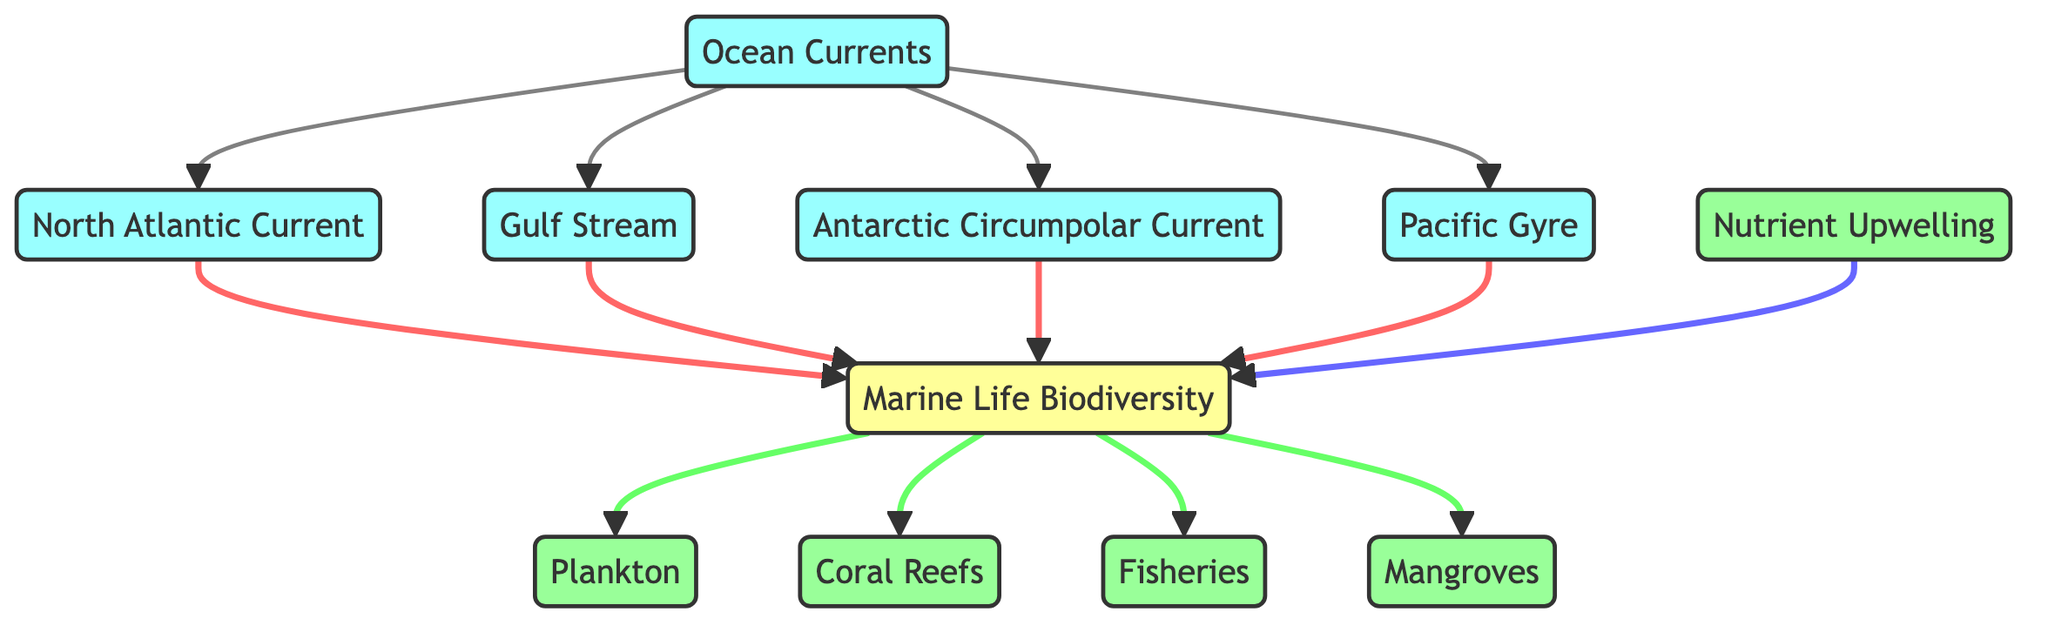What are the main ocean currents represented in the diagram? The diagram lists four main ocean currents: North Atlantic Current, Gulf Stream, Antarctic Circumpolar Current, and Pacific Gyre. Each current is shown as a separate node connected to the Ocean Currents node.
Answer: North Atlantic Current, Gulf Stream, Antarctic Circumpolar Current, Pacific Gyre How many nodes representing marine life biodiversity are there? The Marine Life Biodiversity node has multiple connections leading to four ecosystem nodes: Plankton, Coral Reefs, Fisheries, and Mangroves, which can be counted as four distinct nodes.
Answer: Four Which ocean current connects to the highest number of marine life biodiversity nodes? The diagram shows that both the North Atlantic Current and the Gulf Stream connect to the Marine Life Biodiversity node, leading to the same number of ecosystems. Therefore, both currents can be considered to connect to biodiversity equally.
Answer: North Atlantic Current and Gulf Stream What role does nutrient upwelling play in marine biodiversity? Nutrient Upwelling directly connects to the Marine Life Biodiversity node, indicating its role in providing essential nutrients that enhance biodiversity. This connection shows that nutrient upwelling contributes positively to the overall diversity in marine life.
Answer: Positive contribution How many total edges connect the ocean currents to marine life biodiversity? Each of the four ocean currents connects to the Marine Life Biodiversity node, which then connects to the four ecosystem nodes. Hence, the total edges from ocean currents to marine life biodiversity are four (ocean currents to biodiversity) plus four (biodiversity to ecosystems), totaling eight edges.
Answer: Eight Which ecosystem is directly influenced by the Gulf Stream? The Gulf Stream connects directly to the Marine Life Biodiversity node, which is further linked to several ecosystems. The diagram specifies that this pathway channels its influence to all ecosystem nodes including Plankton, Coral Reefs, Fisheries, and Mangroves.
Answer: All ecosystems connected to the Marine Life Biodiversity Explain the flow of information from ocean currents to coral reefs. First, the Ocean Currents node branches out to the Gulf Stream, which then connects to the Marine Life Biodiversity node. From there, the Marine Life Biodiversity leads directly to the Coral Reefs node. This sequential flow indicates that ocean currents influence the biodiversity, which in turn impacts coral reefs.
Answer: Ocean Currents → Gulf Stream → Marine Life Biodiversity → Coral Reefs Which current does not directly influence marine life biodiversity? Among the currents represented, all of them have direct connections to the Marine Life Biodiversity node, meaning there is no current listed that does not influence it.
Answer: None (all currents influence) 